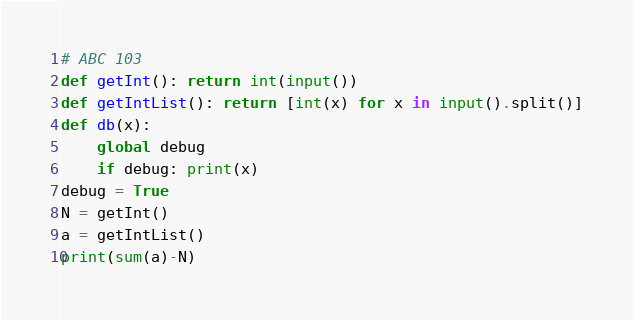Convert code to text. <code><loc_0><loc_0><loc_500><loc_500><_Python_># ABC 103
def getInt(): return int(input())
def getIntList(): return [int(x) for x in input().split()]
def db(x): 
    global debug
    if debug: print(x)
debug = True
N = getInt()
a = getIntList()
print(sum(a)-N)


</code> 